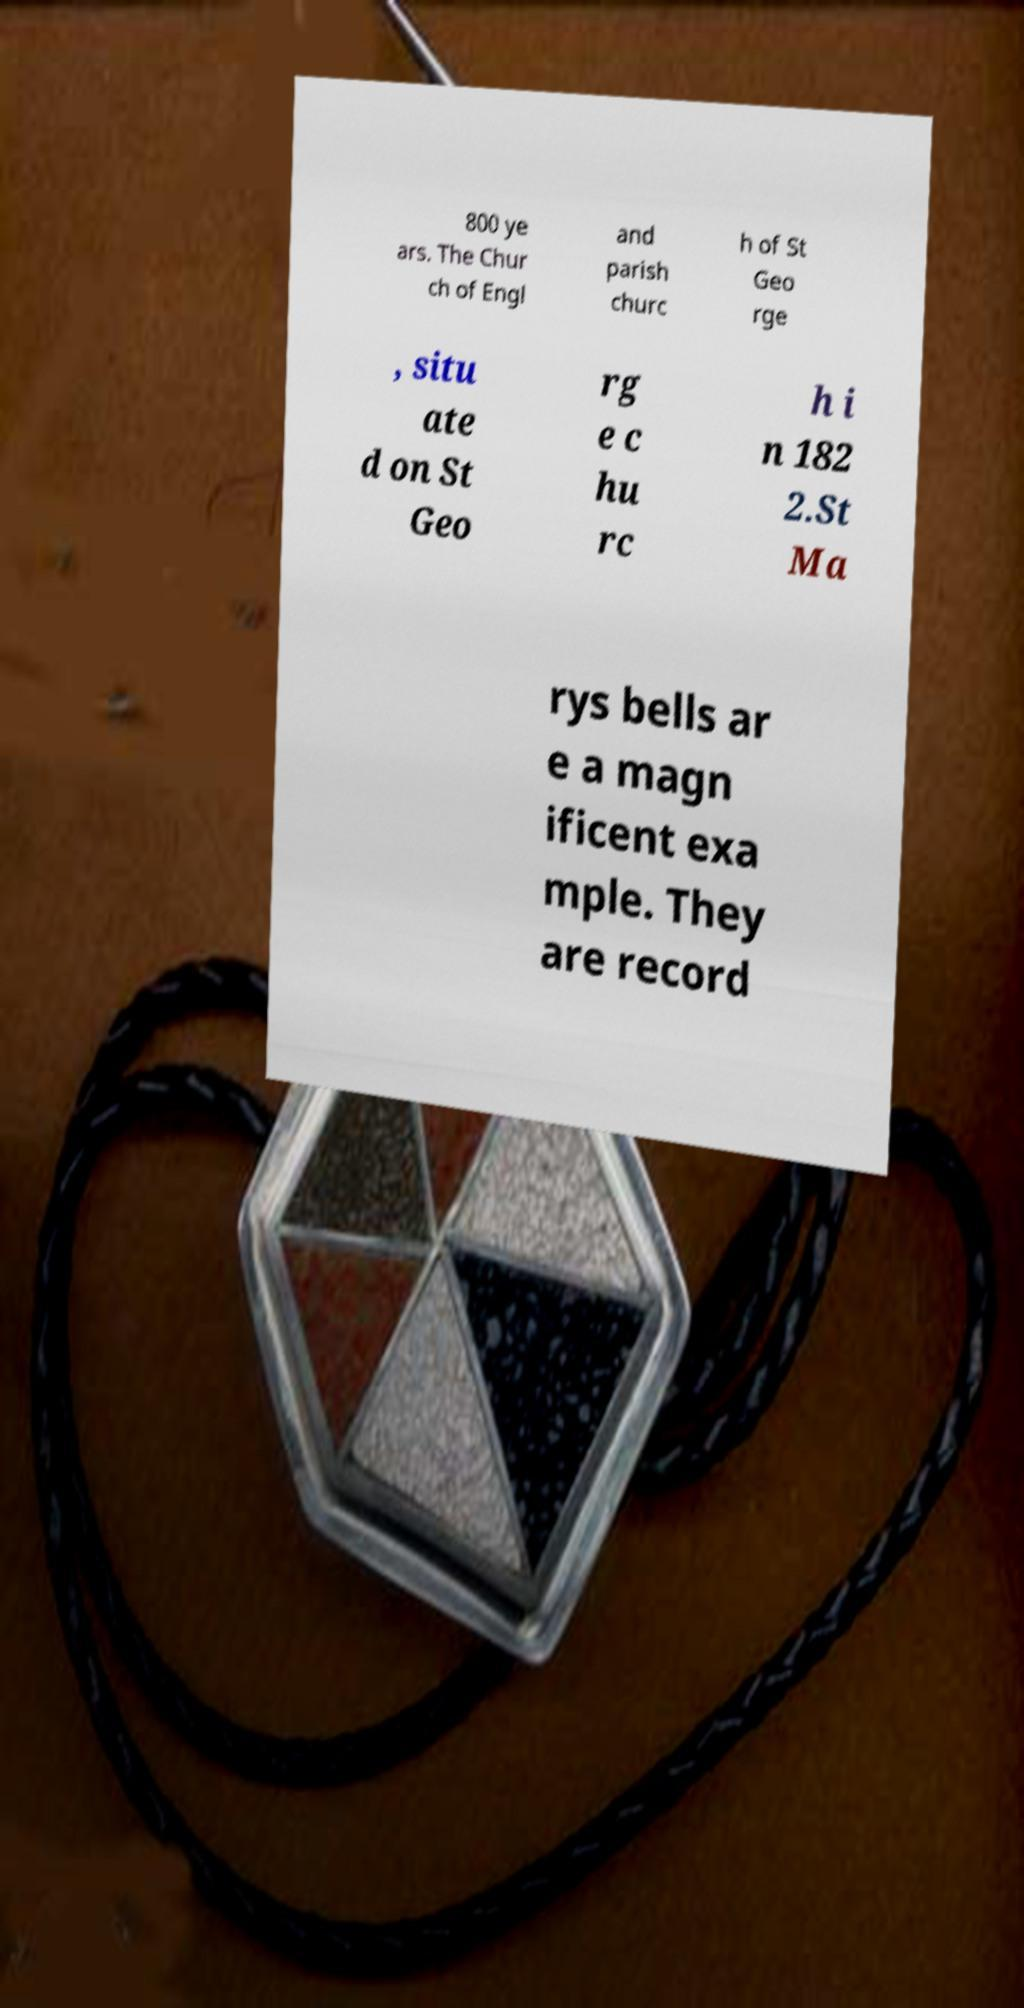Could you extract and type out the text from this image? 800 ye ars. The Chur ch of Engl and parish churc h of St Geo rge , situ ate d on St Geo rg e c hu rc h i n 182 2.St Ma rys bells ar e a magn ificent exa mple. They are record 